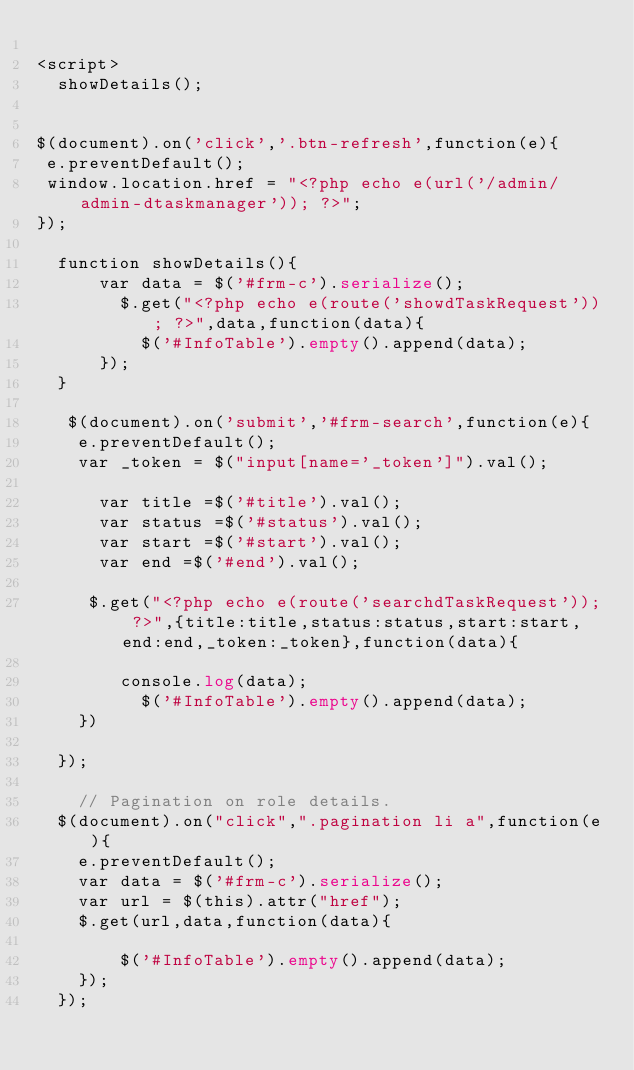Convert code to text. <code><loc_0><loc_0><loc_500><loc_500><_PHP_>
<script>
  showDetails();

 
$(document).on('click','.btn-refresh',function(e){
 e.preventDefault(); 
 window.location.href = "<?php echo e(url('/admin/admin-dtaskmanager')); ?>";
});

  function showDetails(){
      var data = $('#frm-c').serialize();
        $.get("<?php echo e(route('showdTaskRequest')); ?>",data,function(data){
          $('#InfoTable').empty().append(data);
      });
  }

   $(document).on('submit','#frm-search',function(e){
    e.preventDefault();
    var _token = $("input[name='_token']").val();
        
      var title =$('#title').val();
      var status =$('#status').val();
      var start =$('#start').val();
      var end =$('#end').val();

     $.get("<?php echo e(route('searchdTaskRequest')); ?>",{title:title,status:status,start:start,end:end,_token:_token},function(data){
      
        console.log(data);
          $('#InfoTable').empty().append(data);
    })
      
  });

    // Pagination on role details.
  $(document).on("click",".pagination li a",function(e){
    e.preventDefault(); 
    var data = $('#frm-c').serialize();
    var url = $(this).attr("href");
    $.get(url,data,function(data){
         
        $('#InfoTable').empty().append(data);
    });
  });

</code> 